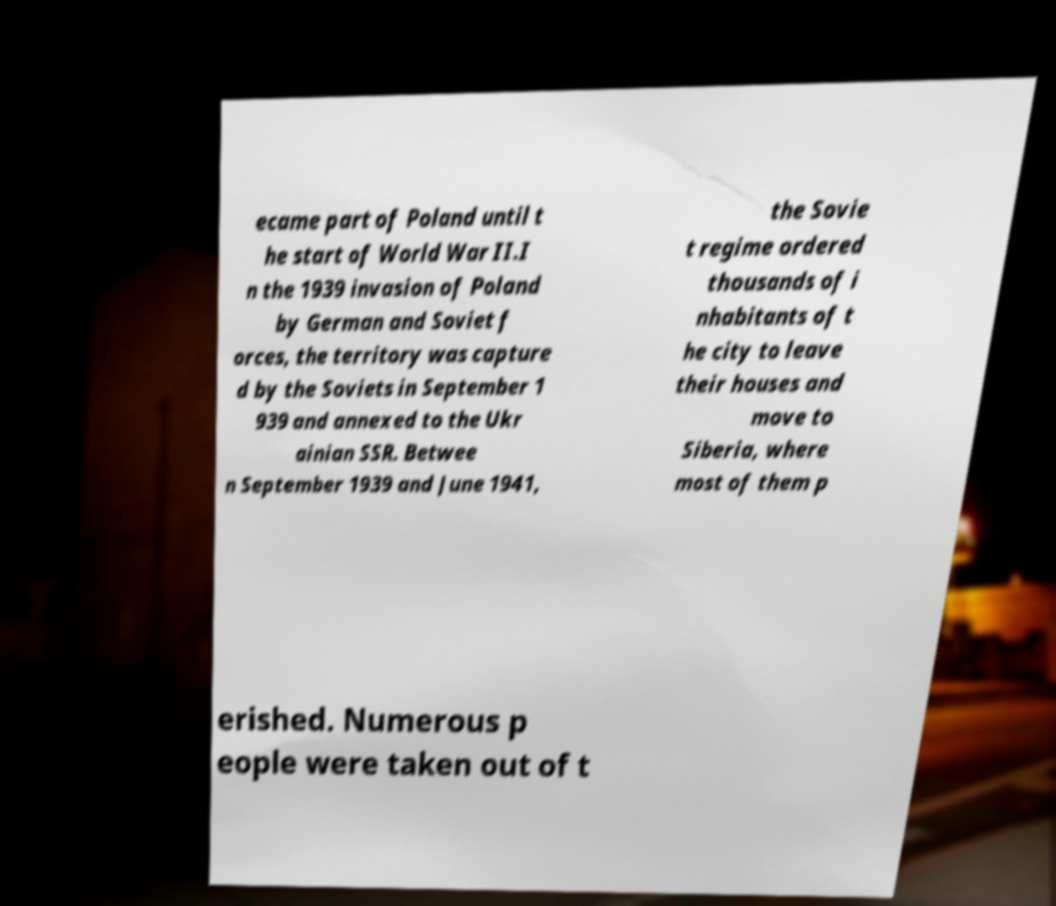Could you extract and type out the text from this image? ecame part of Poland until t he start of World War II.I n the 1939 invasion of Poland by German and Soviet f orces, the territory was capture d by the Soviets in September 1 939 and annexed to the Ukr ainian SSR. Betwee n September 1939 and June 1941, the Sovie t regime ordered thousands of i nhabitants of t he city to leave their houses and move to Siberia, where most of them p erished. Numerous p eople were taken out of t 